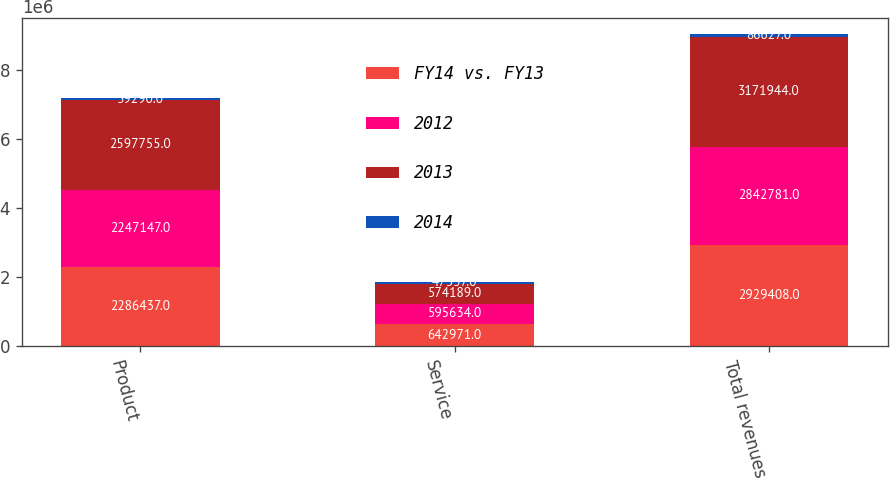Convert chart. <chart><loc_0><loc_0><loc_500><loc_500><stacked_bar_chart><ecel><fcel>Product<fcel>Service<fcel>Total revenues<nl><fcel>FY14 vs. FY13<fcel>2.28644e+06<fcel>642971<fcel>2.92941e+06<nl><fcel>2012<fcel>2.24715e+06<fcel>595634<fcel>2.84278e+06<nl><fcel>2013<fcel>2.59776e+06<fcel>574189<fcel>3.17194e+06<nl><fcel>2014<fcel>39290<fcel>47337<fcel>86627<nl></chart> 